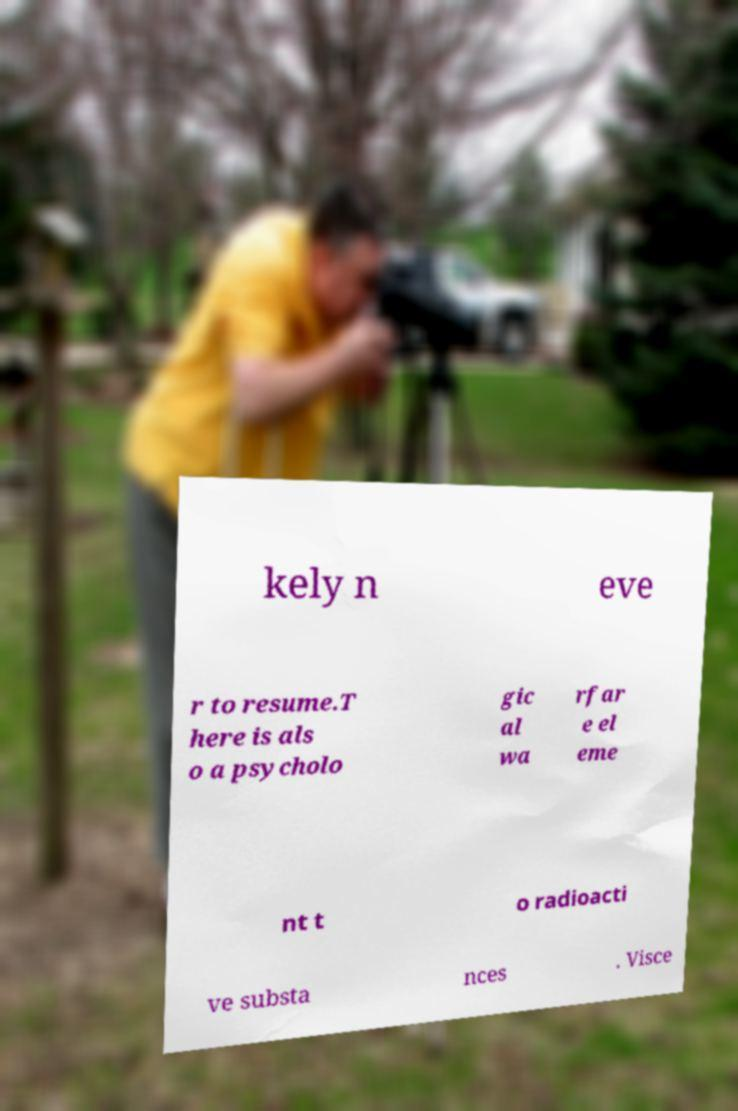There's text embedded in this image that I need extracted. Can you transcribe it verbatim? kely n eve r to resume.T here is als o a psycholo gic al wa rfar e el eme nt t o radioacti ve substa nces . Visce 